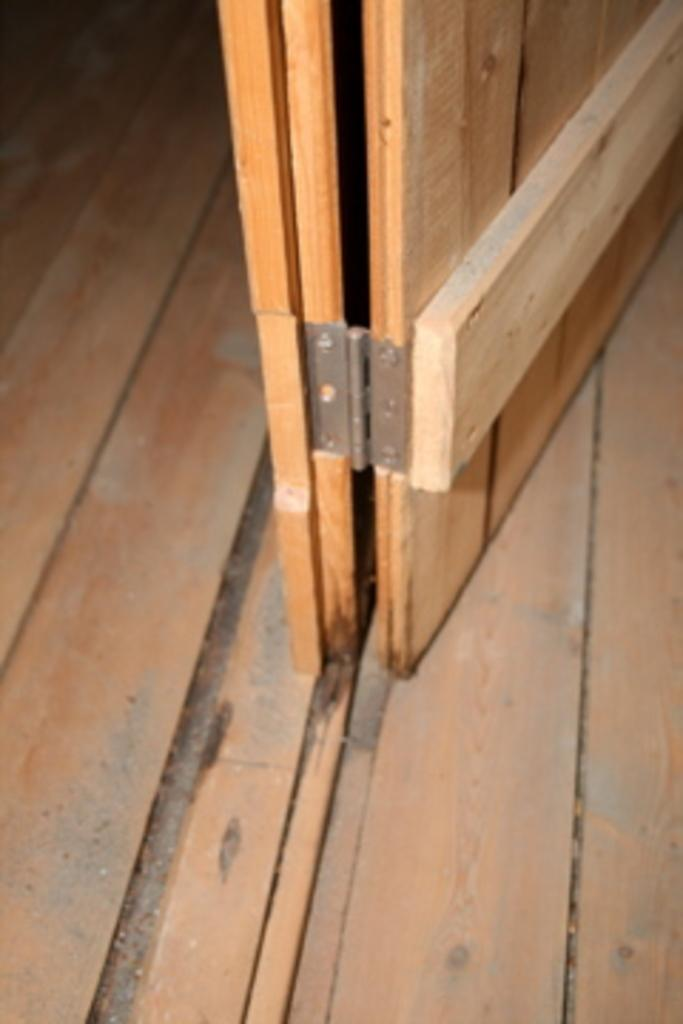What type of door is visible in the image? There is a wooden door in the image. What material is the floor made of in the image? The wooden door is on a wooden floor. How would you describe the background of the image? The background of the image is dark in color. Are there any cobwebs visible on the wooden door in the image? There is no mention of cobwebs in the provided facts, so we cannot determine if any are present in the image. 